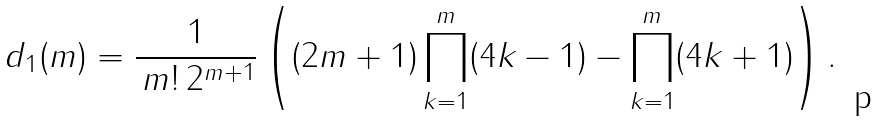Convert formula to latex. <formula><loc_0><loc_0><loc_500><loc_500>d _ { 1 } ( m ) = \frac { 1 } { \, m ! \, 2 ^ { m + 1 } } \left ( ( 2 m + 1 ) \prod _ { k = 1 } ^ { m } ( 4 k - 1 ) - \prod _ { k = 1 } ^ { m } ( 4 k + 1 ) \right ) .</formula> 